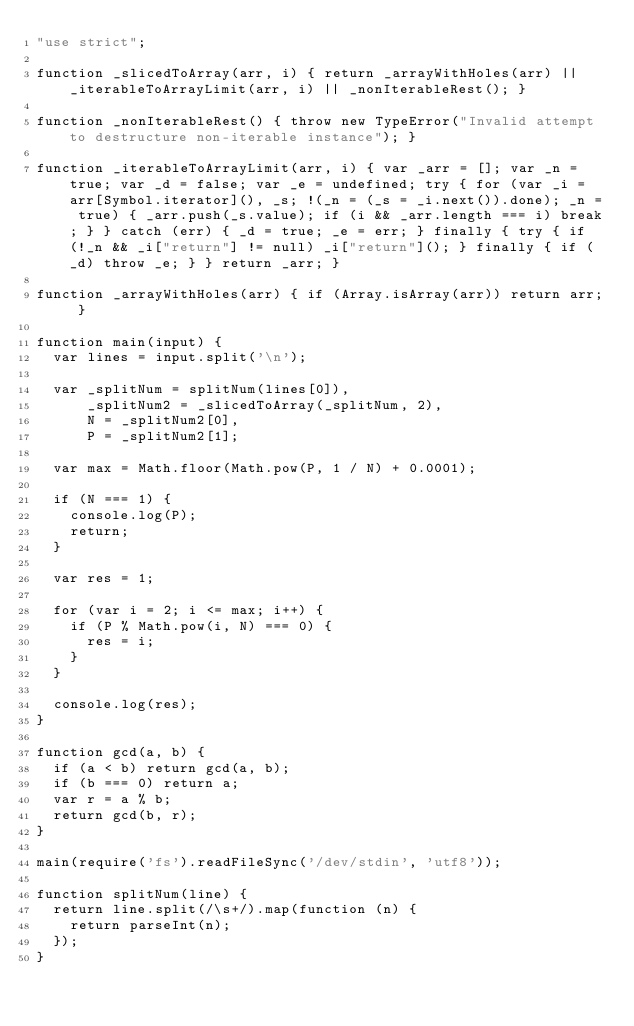Convert code to text. <code><loc_0><loc_0><loc_500><loc_500><_JavaScript_>"use strict";

function _slicedToArray(arr, i) { return _arrayWithHoles(arr) || _iterableToArrayLimit(arr, i) || _nonIterableRest(); }

function _nonIterableRest() { throw new TypeError("Invalid attempt to destructure non-iterable instance"); }

function _iterableToArrayLimit(arr, i) { var _arr = []; var _n = true; var _d = false; var _e = undefined; try { for (var _i = arr[Symbol.iterator](), _s; !(_n = (_s = _i.next()).done); _n = true) { _arr.push(_s.value); if (i && _arr.length === i) break; } } catch (err) { _d = true; _e = err; } finally { try { if (!_n && _i["return"] != null) _i["return"](); } finally { if (_d) throw _e; } } return _arr; }

function _arrayWithHoles(arr) { if (Array.isArray(arr)) return arr; }

function main(input) {
  var lines = input.split('\n');

  var _splitNum = splitNum(lines[0]),
      _splitNum2 = _slicedToArray(_splitNum, 2),
      N = _splitNum2[0],
      P = _splitNum2[1];

  var max = Math.floor(Math.pow(P, 1 / N) + 0.0001);

  if (N === 1) {
    console.log(P);
    return;
  }

  var res = 1;

  for (var i = 2; i <= max; i++) {
    if (P % Math.pow(i, N) === 0) {
      res = i;
    }
  }

  console.log(res);
}

function gcd(a, b) {
  if (a < b) return gcd(a, b);
  if (b === 0) return a;
  var r = a % b;
  return gcd(b, r);
}

main(require('fs').readFileSync('/dev/stdin', 'utf8'));

function splitNum(line) {
  return line.split(/\s+/).map(function (n) {
    return parseInt(n);
  });
}
</code> 